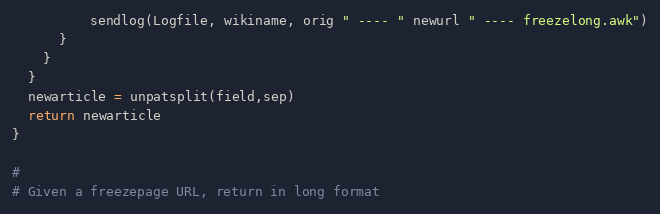Convert code to text. <code><loc_0><loc_0><loc_500><loc_500><_Awk_>          sendlog(Logfile, wikiname, orig " ---- " newurl " ---- freezelong.awk")
      }
    }
  }
  newarticle = unpatsplit(field,sep)
  return newarticle
}

#
# Given a freezepage URL, return in long format </code> 